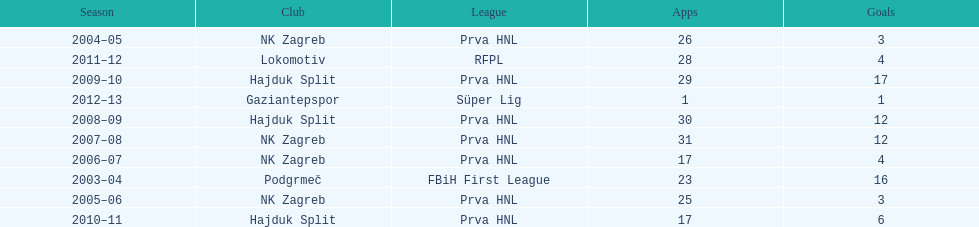Would you mind parsing the complete table? {'header': ['Season', 'Club', 'League', 'Apps', 'Goals'], 'rows': [['2004–05', 'NK Zagreb', 'Prva HNL', '26', '3'], ['2011–12', 'Lokomotiv', 'RFPL', '28', '4'], ['2009–10', 'Hajduk Split', 'Prva HNL', '29', '17'], ['2012–13', 'Gaziantepspor', 'Süper Lig', '1', '1'], ['2008–09', 'Hajduk Split', 'Prva HNL', '30', '12'], ['2007–08', 'NK Zagreb', 'Prva HNL', '31', '12'], ['2006–07', 'NK Zagreb', 'Prva HNL', '17', '4'], ['2003–04', 'Podgrmeč', 'FBiH First League', '23', '16'], ['2005–06', 'NK Zagreb', 'Prva HNL', '25', '3'], ['2010–11', 'Hajduk Split', 'Prva HNL', '17', '6']]} At most 26 apps, how many goals were scored in 2004-2005 3. 